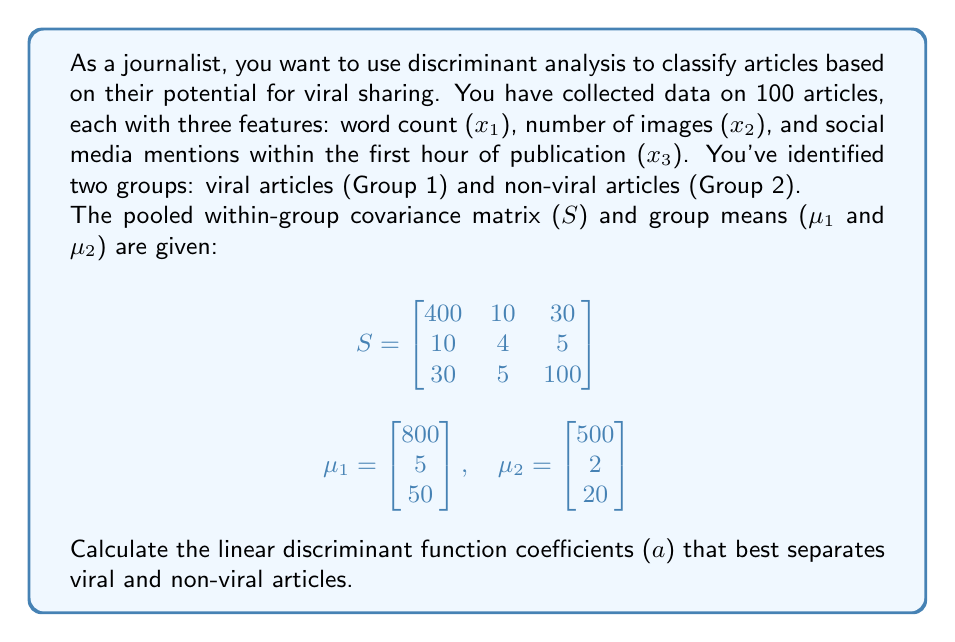Help me with this question. To calculate the linear discriminant function coefficients, we'll follow these steps:

1) The linear discriminant function is of the form:
   $$a'x = a_1x_1 + a_2x_2 + a_3x_3$$

2) The coefficients (a) are calculated using the formula:
   $$a = S^{-1}(\mu_1 - \mu_2)$$

3) First, we need to find the inverse of S. Using a calculator or computer algebra system:
   $$S^{-1} = \begin{bmatrix}
   0.0025 & -0.0059 & -0.0007 \\
   -0.0059 & 0.2627 & -0.0011 \\
   -0.0007 & -0.0011 & 0.0102
   \end{bmatrix}$$

4) Next, we calculate the difference between the group means:
   $$\mu_1 - \mu_2 = \begin{bmatrix} 800 \\ 5 \\ 50 \end{bmatrix} - \begin{bmatrix} 500 \\ 2 \\ 20 \end{bmatrix} = \begin{bmatrix} 300 \\ 3 \\ 30 \end{bmatrix}$$

5) Now, we multiply S^(-1) by (μ₁ - μ₂):
   $$a = S^{-1}(\mu_1 - \mu_2) = \begin{bmatrix}
   0.0025 & -0.0059 & -0.0007 \\
   -0.0059 & 0.2627 & -0.0011 \\
   -0.0007 & -0.0011 & 0.0102
   \end{bmatrix} \begin{bmatrix} 300 \\ 3 \\ 30 \end{bmatrix}$$

6) Performing the matrix multiplication:
   $$a = \begin{bmatrix} 0.6087 \\ 0.5655 \\ 0.2988 \end{bmatrix}$$

These are the coefficients of the linear discriminant function that best separates viral and non-viral articles.
Answer: $a = (0.6087, 0.5655, 0.2988)$ 